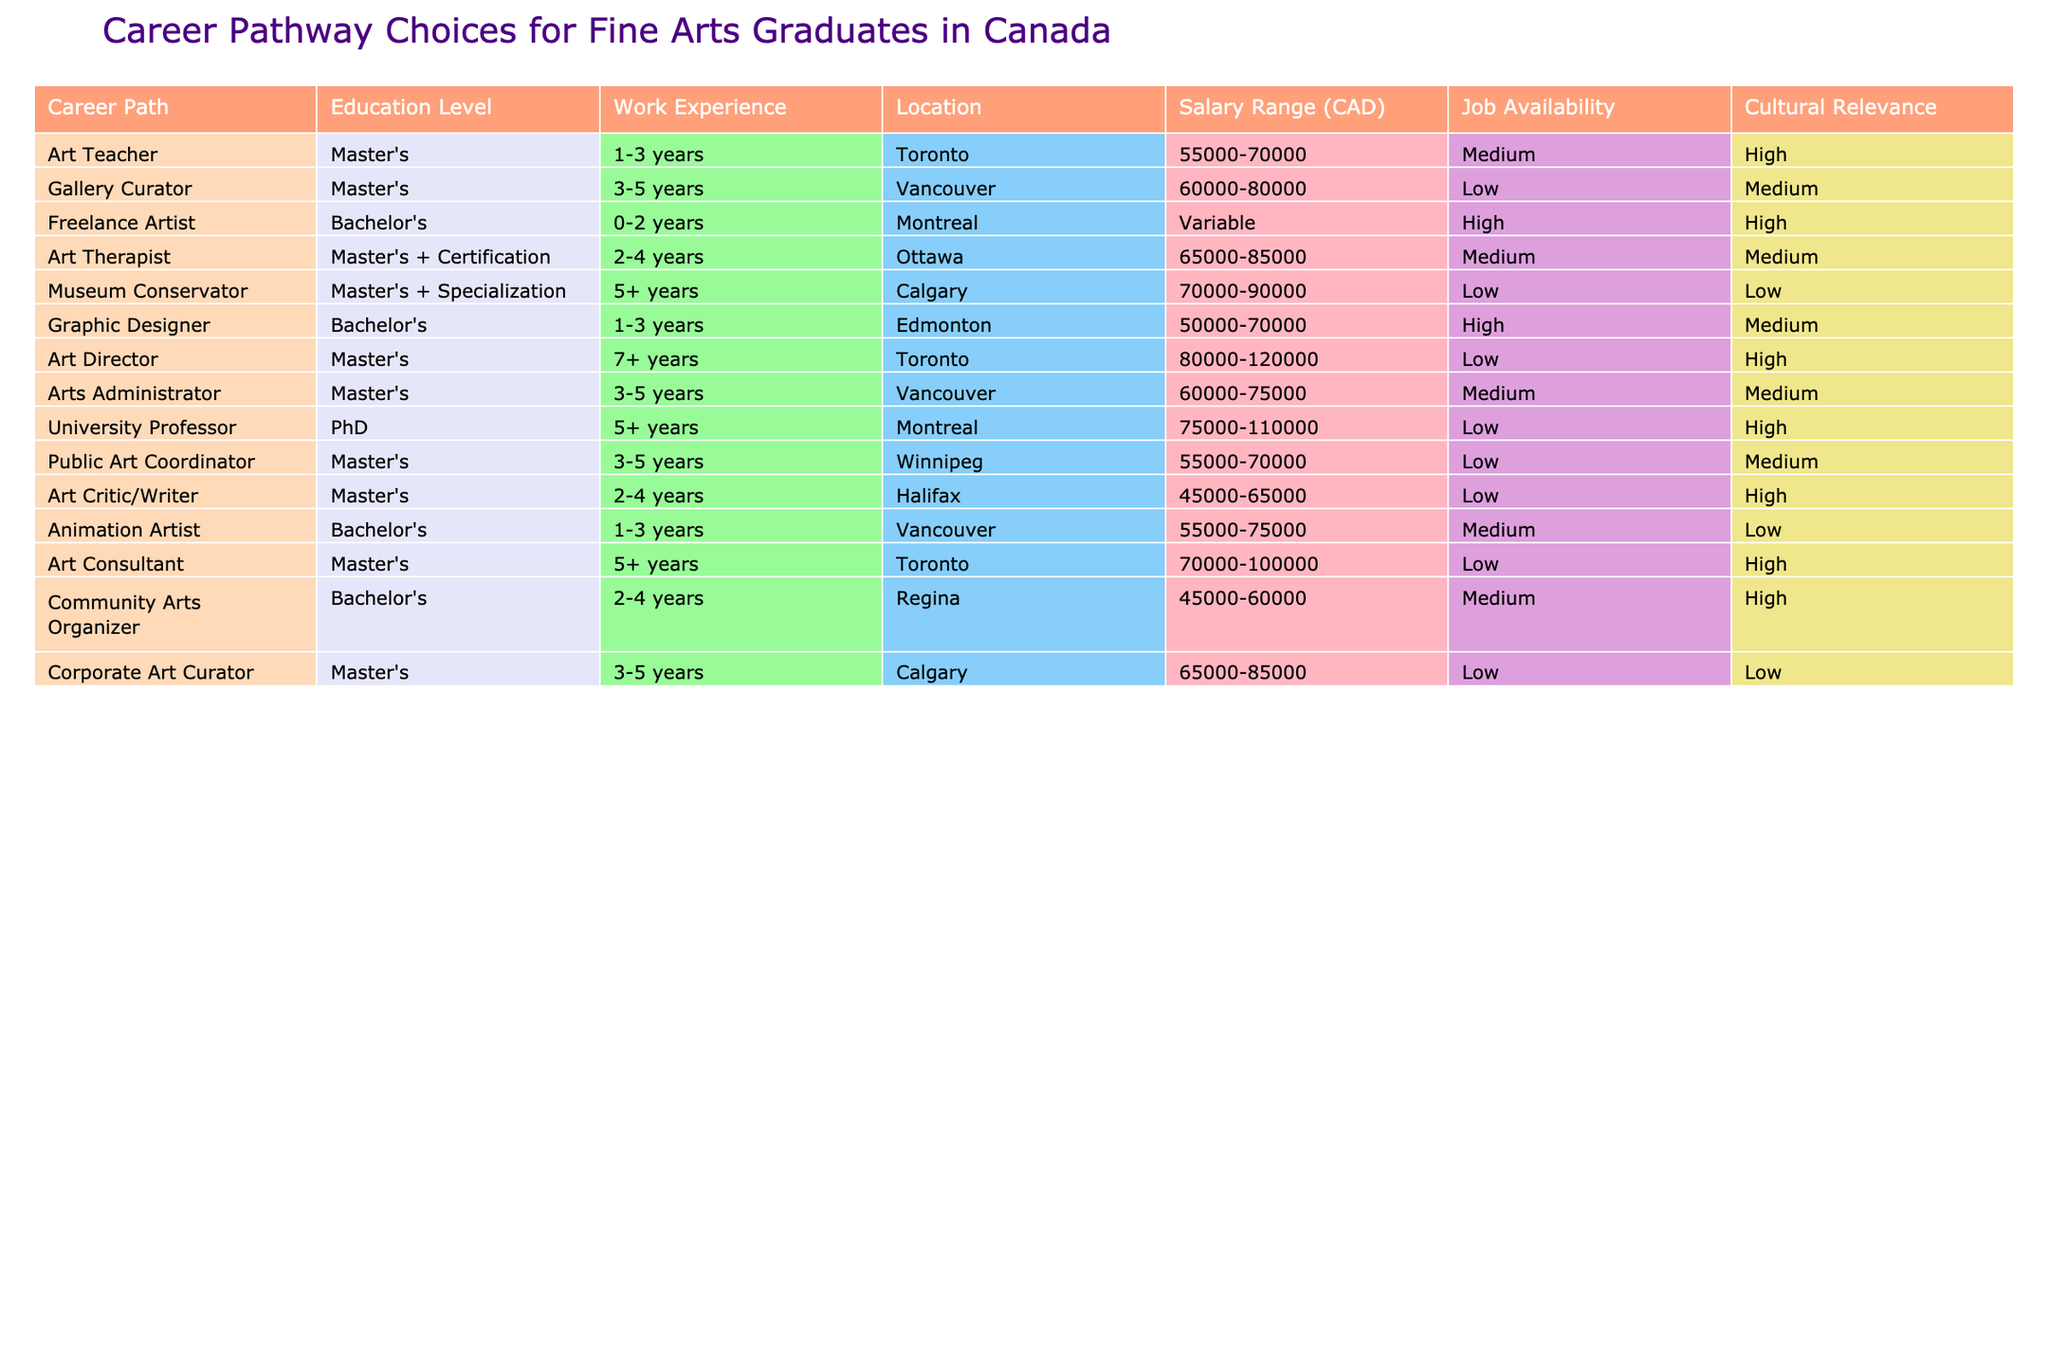What is the highest salary range for careers listed in the table? The highest salary range listed is for the Art Director position, which has a range of 80000-120000 CAD.
Answer: 80000-120000 CAD Which career has the lowest job availability? The job availability for Museum Conservator, Gallery Curator, and Corporate Art Curator is listed as Low, making them the careers with the lowest job availability in the table.
Answer: Museum Conservator, Gallery Curator, Corporate Art Curator How many careers require a Master's degree? Out of the careers listed, 7 require a Master's degree as the education level, which can be identified by counting the rows with "Master's" under the Education Level column.
Answer: 7 What is the average salary range of "Art Therapist" and "Art Critic/Writer"? The average salary range for Art Therapist is 65000-85000 CAD and for Art Critic/Writer is 45000-65000 CAD. To find the overall average range, we consider both ranges: The average of 65000 and 45000 is 55000, and the average of 85000 and 65000 is 75000. Thus, the average is from 55000-75000 CAD.
Answer: 55000-75000 CAD Is it true that all careers requiring a PhD have low job availability? No, the only career that requires a PhD is University Professor, which is listed as having Low job availability. To verify, we check that it is the only PhD job on the list and its availability status.
Answer: No Which location has the highest salary range for Fine Arts graduates? The location with the highest salary range is Toronto, with the Art Director position offering a salary range of 80000-120000 CAD.
Answer: Toronto What is the total number of career paths listed for graduates with a Bachelor's degree? There are three career paths available for graduates with a Bachelor's degree: Freelance Artist, Graphic Designer, and Animation Artist, which can be identified by filtering the table for Education Level as Bachelor's.
Answer: 3 Which career offers high cultural relevance but low job availability? The Art Critic/Writer position offers high cultural relevance and is rated with low job availability, which is found by inspecting the Cultural Relevance and Job Availability columns for combinations that match this criteria.
Answer: Art Critic/Writer What is the salary difference between the Gallery Curator and the Museum Conservator positions? The salary range for Gallery Curator is 60000-80000 CAD and for Museum Conservator it is 70000-90000 CAD. The difference can be calculated as follows: For the lower end, 70000 - 60000 = 10000, and for the upper end, 90000 - 80000 = 10000, showing a consistent difference of 10000 CAD.
Answer: 10000 CAD 